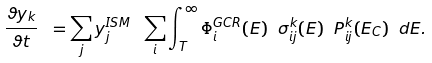<formula> <loc_0><loc_0><loc_500><loc_500>\frac { \vartheta y _ { k } } { \vartheta t } \ = \sum _ { j } y _ { j } ^ { I S M } \ \sum _ { i } \int _ { T } ^ { \infty } \Phi _ { i } ^ { G C R } ( E ) \ \sigma _ { i j } ^ { k } ( E ) \ P _ { i j } ^ { k } ( E _ { C } ) \ d E .</formula> 